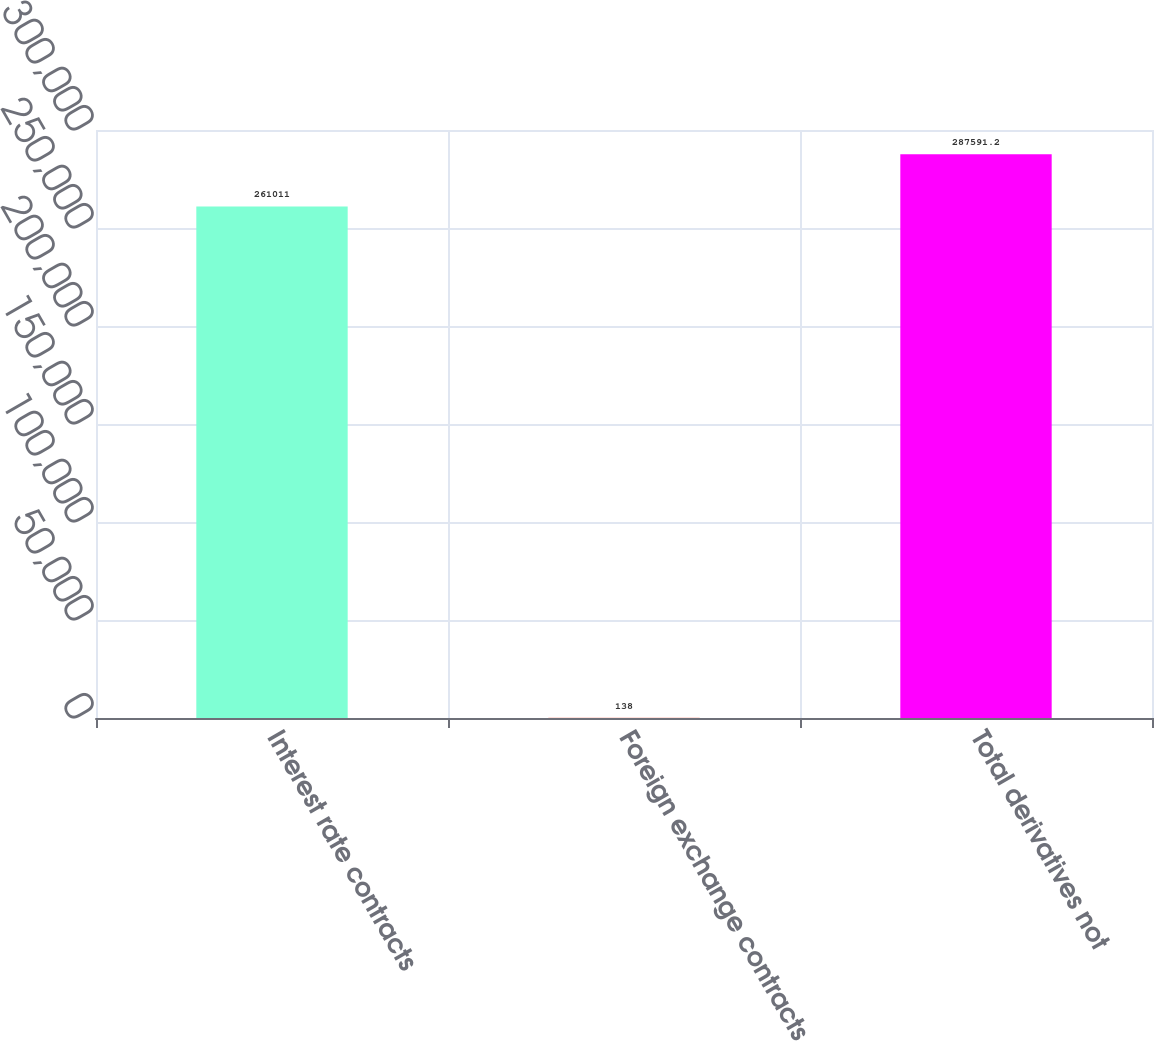Convert chart. <chart><loc_0><loc_0><loc_500><loc_500><bar_chart><fcel>Interest rate contracts<fcel>Foreign exchange contracts<fcel>Total derivatives not<nl><fcel>261011<fcel>138<fcel>287591<nl></chart> 